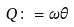<formula> <loc_0><loc_0><loc_500><loc_500>Q \colon = \omega \theta</formula> 